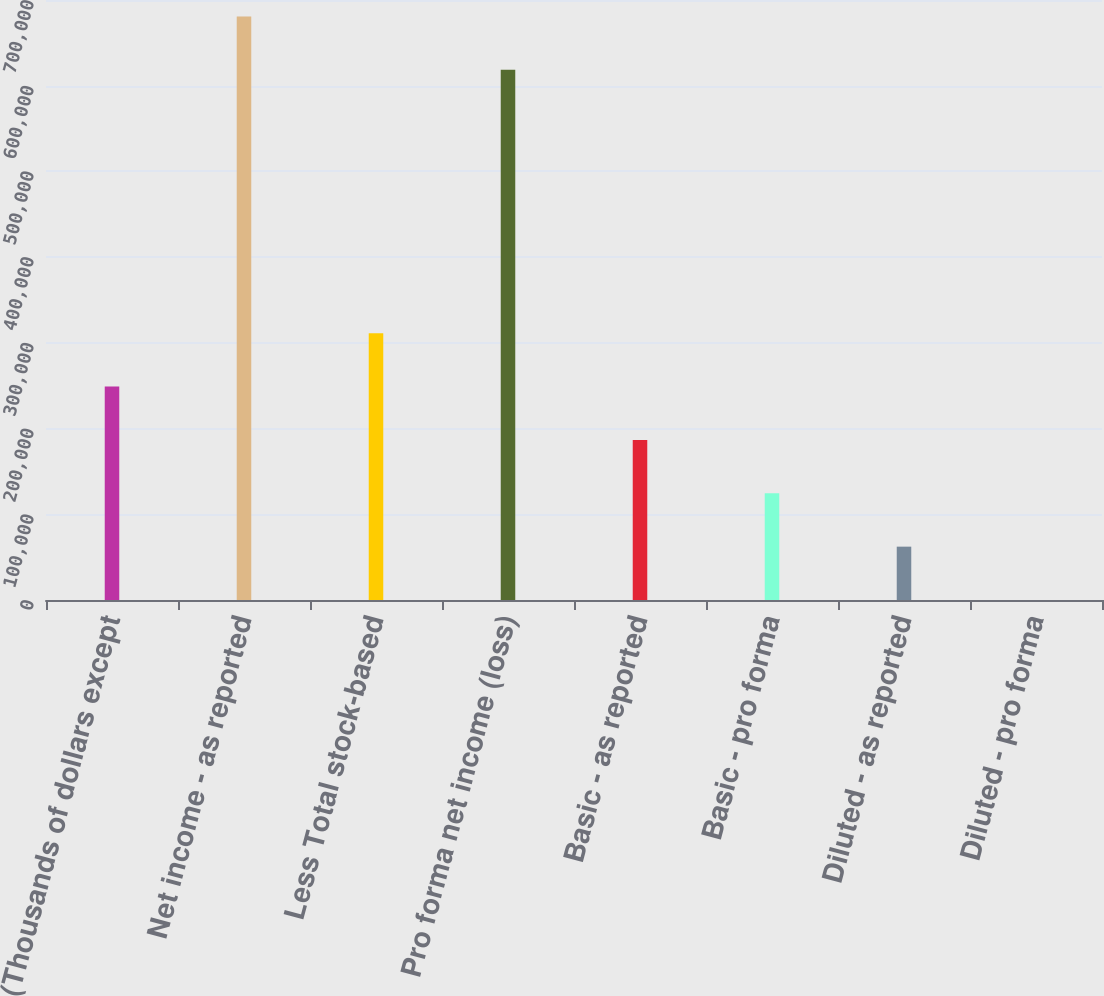Convert chart to OTSL. <chart><loc_0><loc_0><loc_500><loc_500><bar_chart><fcel>(Thousands of dollars except<fcel>Net income - as reported<fcel>Less Total stock-based<fcel>Pro forma net income (loss)<fcel>Basic - as reported<fcel>Basic - pro forma<fcel>Diluted - as reported<fcel>Diluted - pro forma<nl><fcel>248958<fcel>680734<fcel>311197<fcel>618495<fcel>186719<fcel>124480<fcel>62240.5<fcel>1.49<nl></chart> 